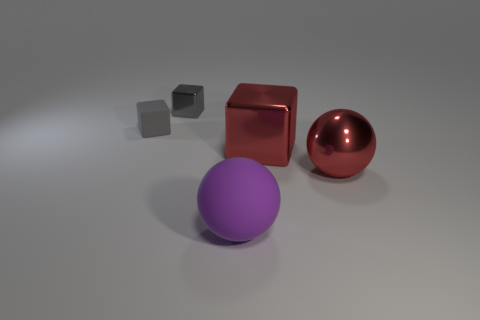Are there any gray cubes that are in front of the rubber object behind the metallic cube in front of the gray metal cube?
Your response must be concise. No. What is the shape of the tiny rubber thing?
Provide a succinct answer. Cube. Are the gray block that is to the left of the gray shiny block and the big ball to the right of the large purple sphere made of the same material?
Give a very brief answer. No. How many matte blocks have the same color as the small rubber thing?
Provide a short and direct response. 0. There is a object that is left of the big red metal block and in front of the gray rubber block; what is its shape?
Your answer should be compact. Sphere. What is the color of the thing that is in front of the big shiny block and left of the big metal ball?
Offer a very short reply. Purple. Is the number of metal balls that are behind the large rubber thing greater than the number of rubber spheres left of the tiny matte object?
Keep it short and to the point. Yes. What color is the rubber object behind the large red block?
Make the answer very short. Gray. There is a gray object in front of the tiny metallic block; is its shape the same as the large red shiny thing that is in front of the big red metallic cube?
Ensure brevity in your answer.  No. Is there another metallic sphere of the same size as the red sphere?
Give a very brief answer. No. 